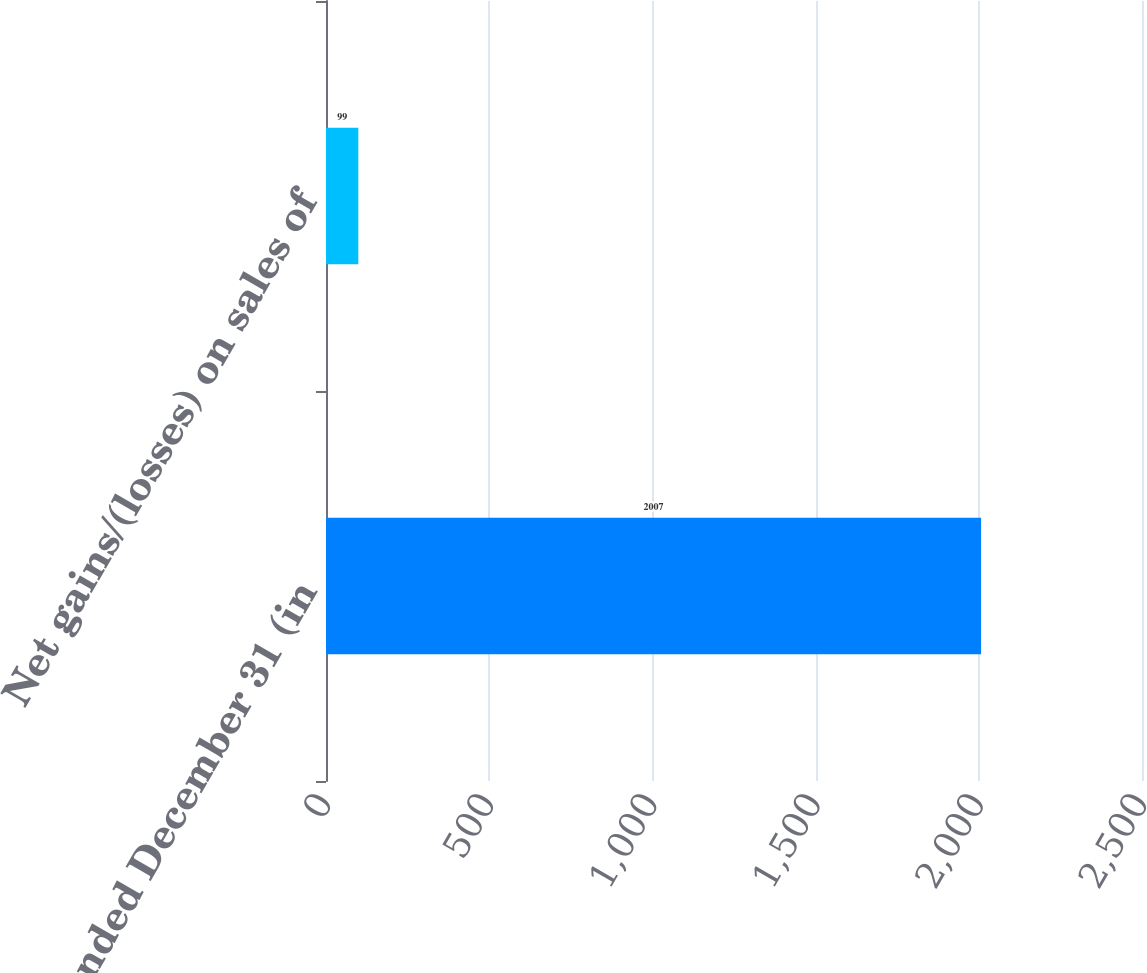Convert chart to OTSL. <chart><loc_0><loc_0><loc_500><loc_500><bar_chart><fcel>Year ended December 31 (in<fcel>Net gains/(losses) on sales of<nl><fcel>2007<fcel>99<nl></chart> 